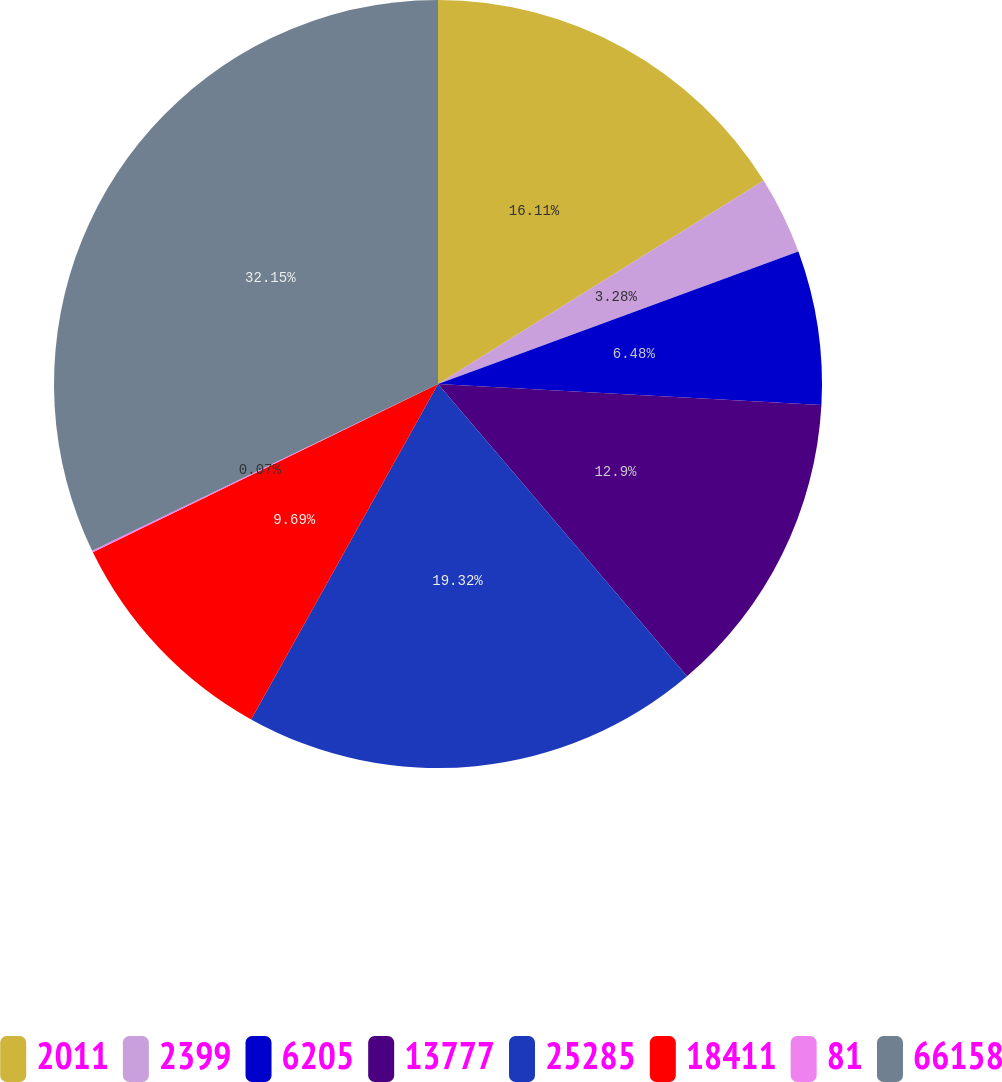<chart> <loc_0><loc_0><loc_500><loc_500><pie_chart><fcel>2011<fcel>2399<fcel>6205<fcel>13777<fcel>25285<fcel>18411<fcel>81<fcel>66158<nl><fcel>16.11%<fcel>3.28%<fcel>6.48%<fcel>12.9%<fcel>19.32%<fcel>9.69%<fcel>0.07%<fcel>32.15%<nl></chart> 